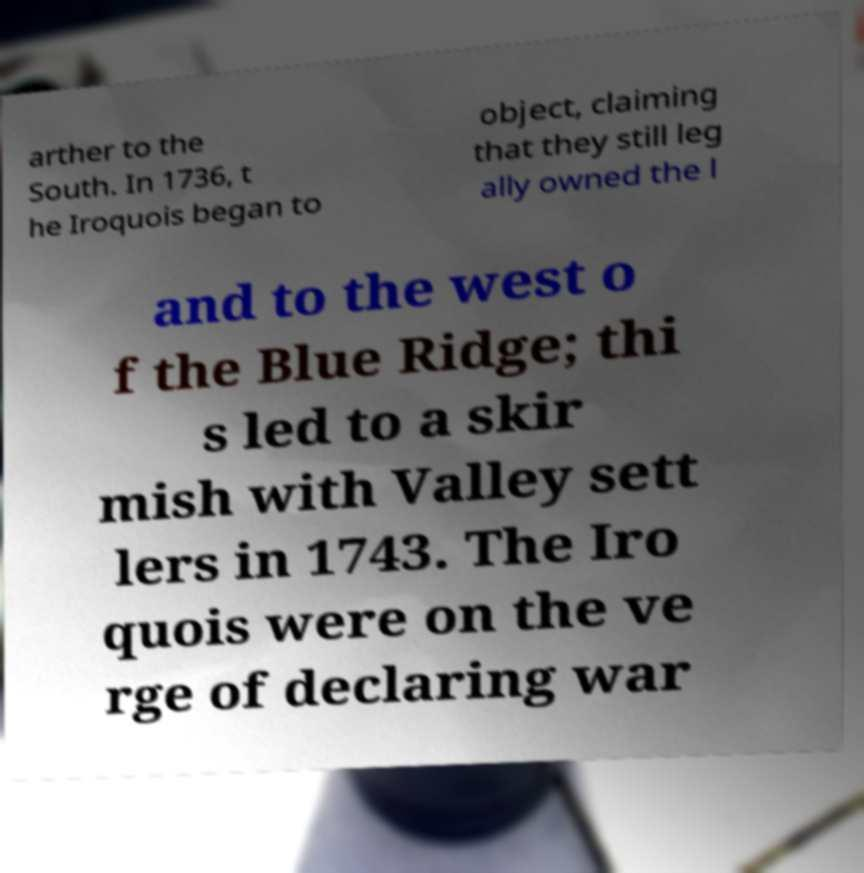What messages or text are displayed in this image? I need them in a readable, typed format. arther to the South. In 1736, t he Iroquois began to object, claiming that they still leg ally owned the l and to the west o f the Blue Ridge; thi s led to a skir mish with Valley sett lers in 1743. The Iro quois were on the ve rge of declaring war 